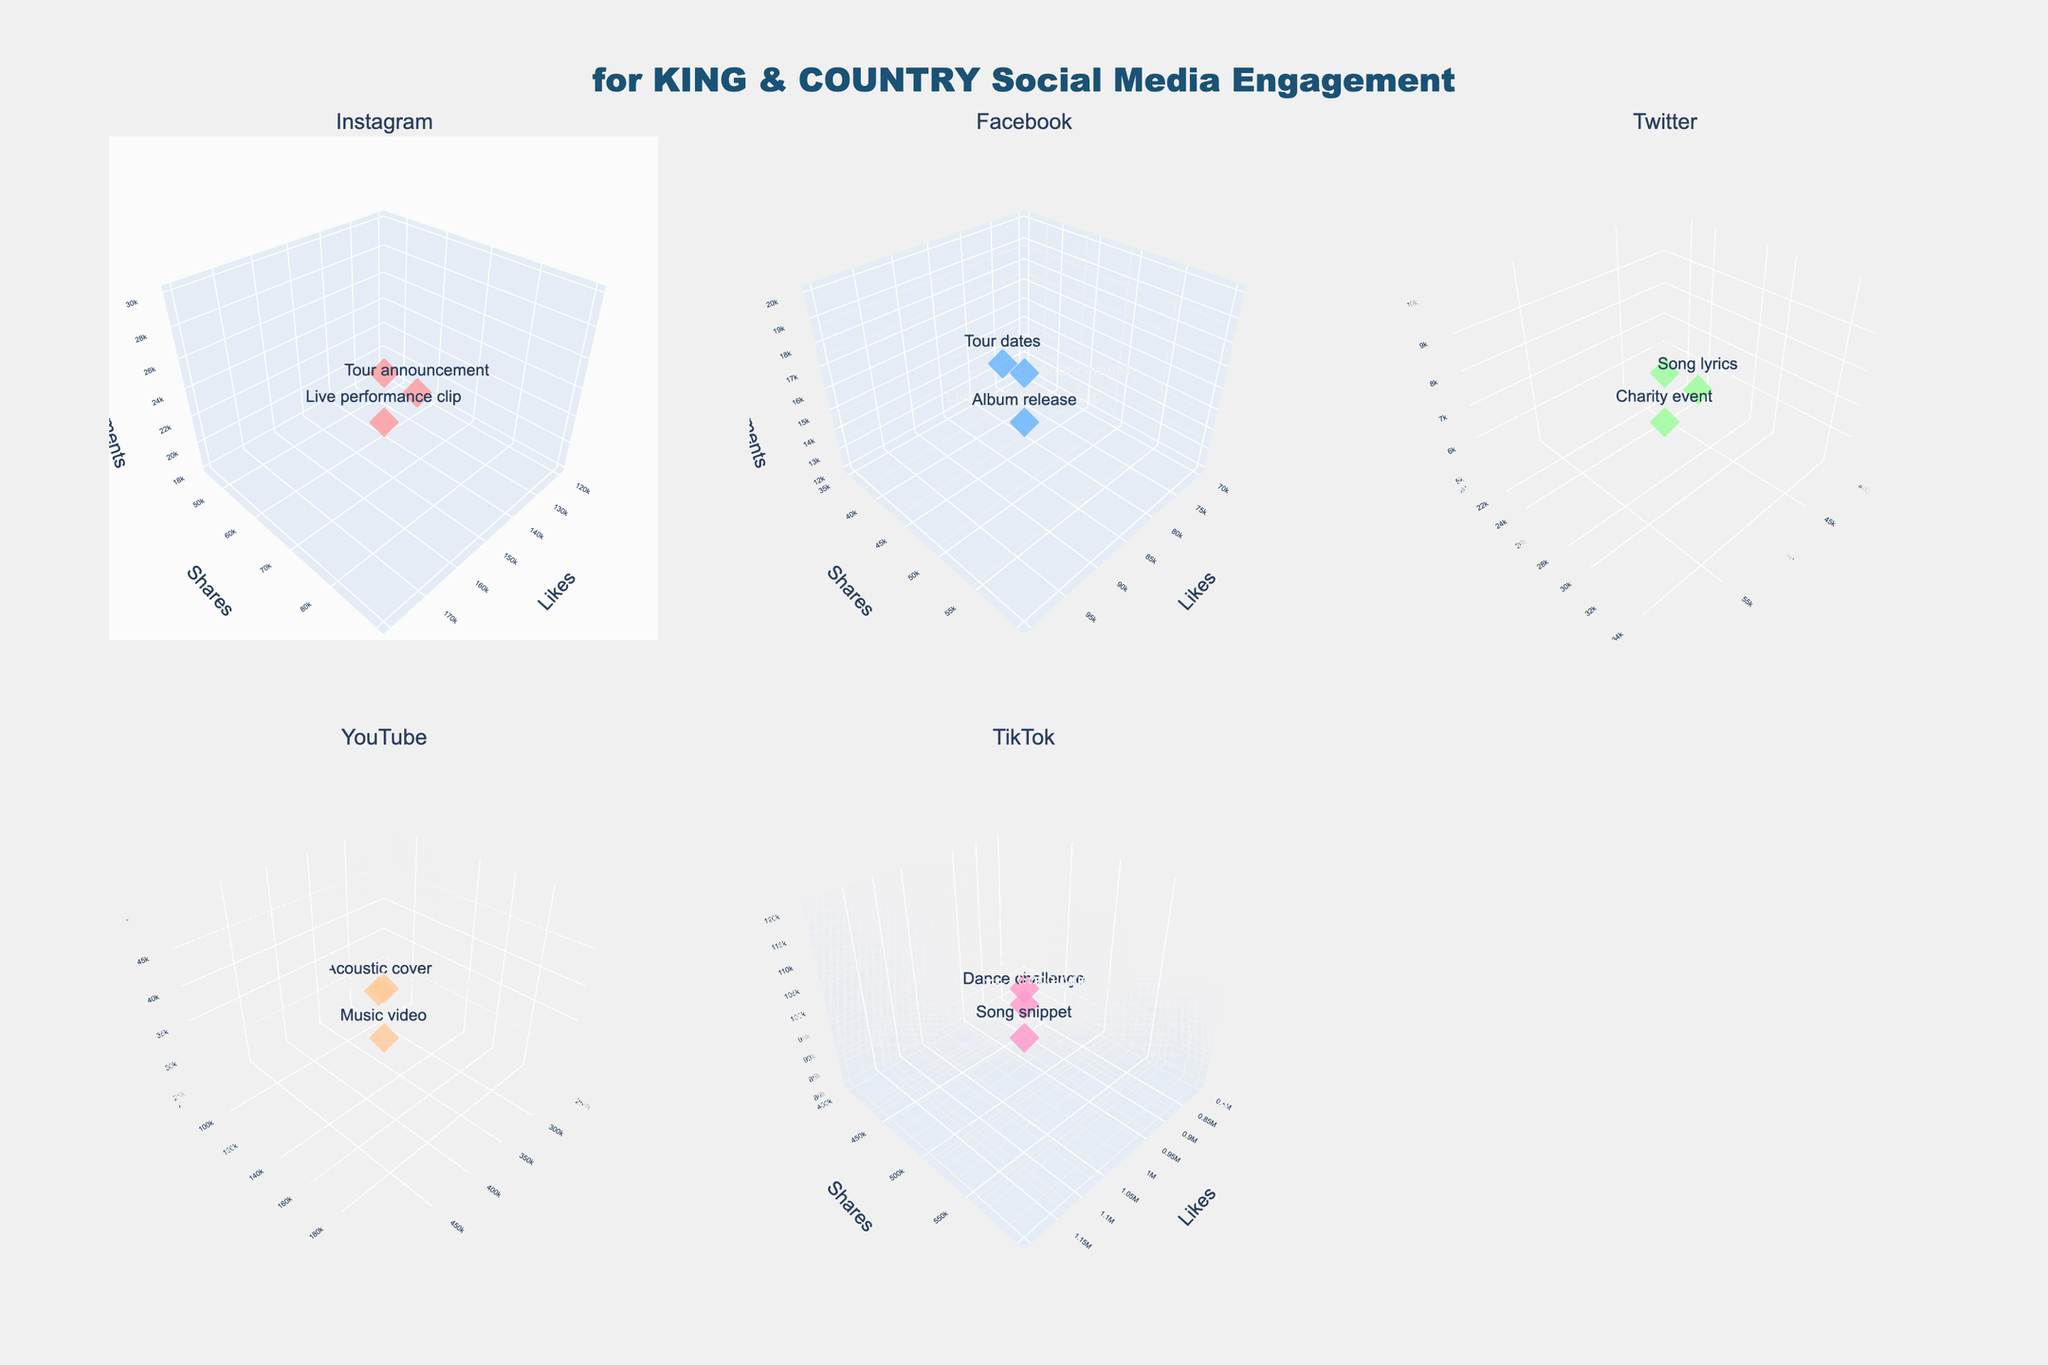How many different social media platforms are included in the figure? The subplot titles represent different social media platforms. There are 4 unique platforms labeled in the subplots.
Answer: 4 Which post type on TikTok has the highest likes? To find the post type with the highest likes on TikTok, locate the TikTok subplot and identify the data point with the highest value on the likes axis. The highest likes value is for "Song snippet" with 1,200,000 likes.
Answer: Song snippet Which platform has the most consistent engagement (similar likes, shares, and comments) across its posts? To determine consistency, look at the spread of data points in each subplot. The platform with the data points closest together across all three axes (likes, shares, comments) signifies consistency. Instagram shows less spread, indicating more consistency.
Answer: Instagram What is the average number of likes for YouTube posts? To calculate the average likes for YouTube, sum the likes values for all YouTube posts and divide by the number of YouTube posts: (500,000 + 300,000 + 250,000) / 3 = 1,050,000 / 3.
Answer: 350,000 On which platform does "Dance challenge" get the most engagement (highest combined likes, shares, and comments)? Total engagement is the sum of likes, shares, and comments. For "Dance challenge" on TikTok: 1,000,000 likes + 500,000 shares + 100,000 comments = 1,600,000.
Answer: TikTok Compare the engagement level of "Tour vlog" on YouTube and "Tour announcement" on Instagram in terms of likes. Which one has more likes? Look at the likes axis in YouTube for "Tour vlog" (250,000) and Instagram for "Tour announcement" (150,000).
Answer: "Tour vlog" on YouTube Which post type has the highest shares on Facebook? To find the post type with the highest shares on Facebook, locate the data point with the highest value on the shares axis within the Facebook subplot. "Album release" has the highest shares with 60,000.
Answer: Album release How many post types on Twitter received less than 40,000 likes? In the Twitter subplot, count the number of data points where the likes value is below 40,000. The data points include "Merchandise promo" and "Charity event."
Answer: 2 Which platform's posts are the least commented on on average? Calculate the average comments per post for each platform and compare. For example, Twitter: (8,000 + 5,000 + 10,000) / 3 = 23,000 / 3 ≈ 7,667. Compare this with other platforms. Twitter has the lowest average comments.
Answer: Twitter In which subplot is the post type with the highest combination of likes, shares, and comments and what is it? The highest combination is identified by summing likes, shares, and comments for each data point and finding the maximum total. The data point in the TikTok subplot with 1,200,000 likes, 600,000 shares, and 120,000 comments for "Song snippet" sums to the highest engagement: 1,920,000.
Answer: TikTok, Song snippet 